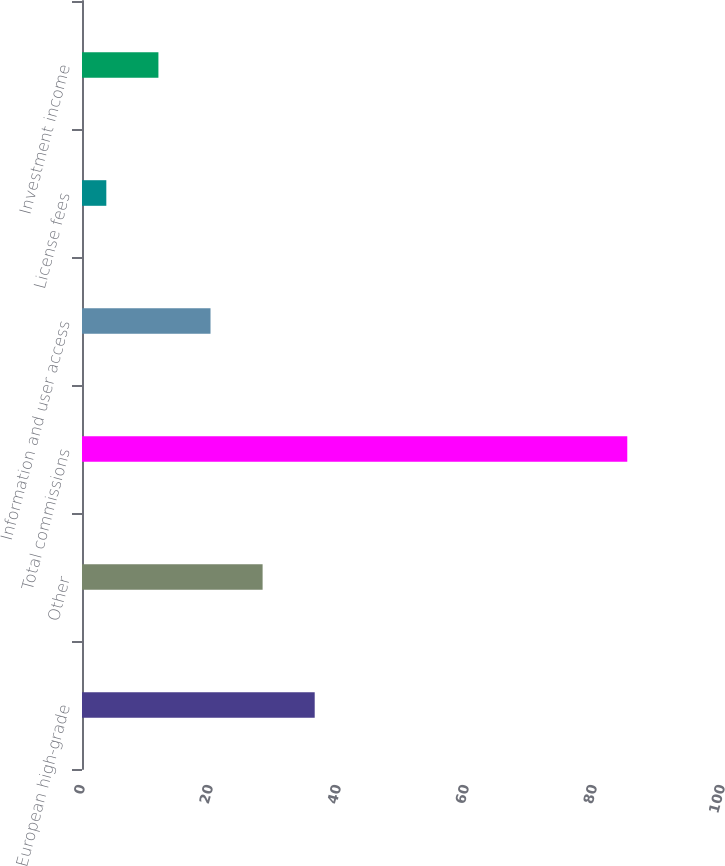Convert chart. <chart><loc_0><loc_0><loc_500><loc_500><bar_chart><fcel>European high-grade<fcel>Other<fcel>Total commissions<fcel>Information and user access<fcel>License fees<fcel>Investment income<nl><fcel>36.36<fcel>28.22<fcel>85.2<fcel>20.08<fcel>3.8<fcel>11.94<nl></chart> 